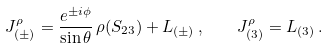<formula> <loc_0><loc_0><loc_500><loc_500>J ^ { \rho } _ { ( \pm ) } = \frac { e ^ { \pm i \phi } } { \sin \theta } \, \rho ( S _ { 2 3 } ) + L _ { ( \pm ) } \, , \quad J ^ { \rho } _ { ( 3 ) } = L _ { ( 3 ) } \, .</formula> 